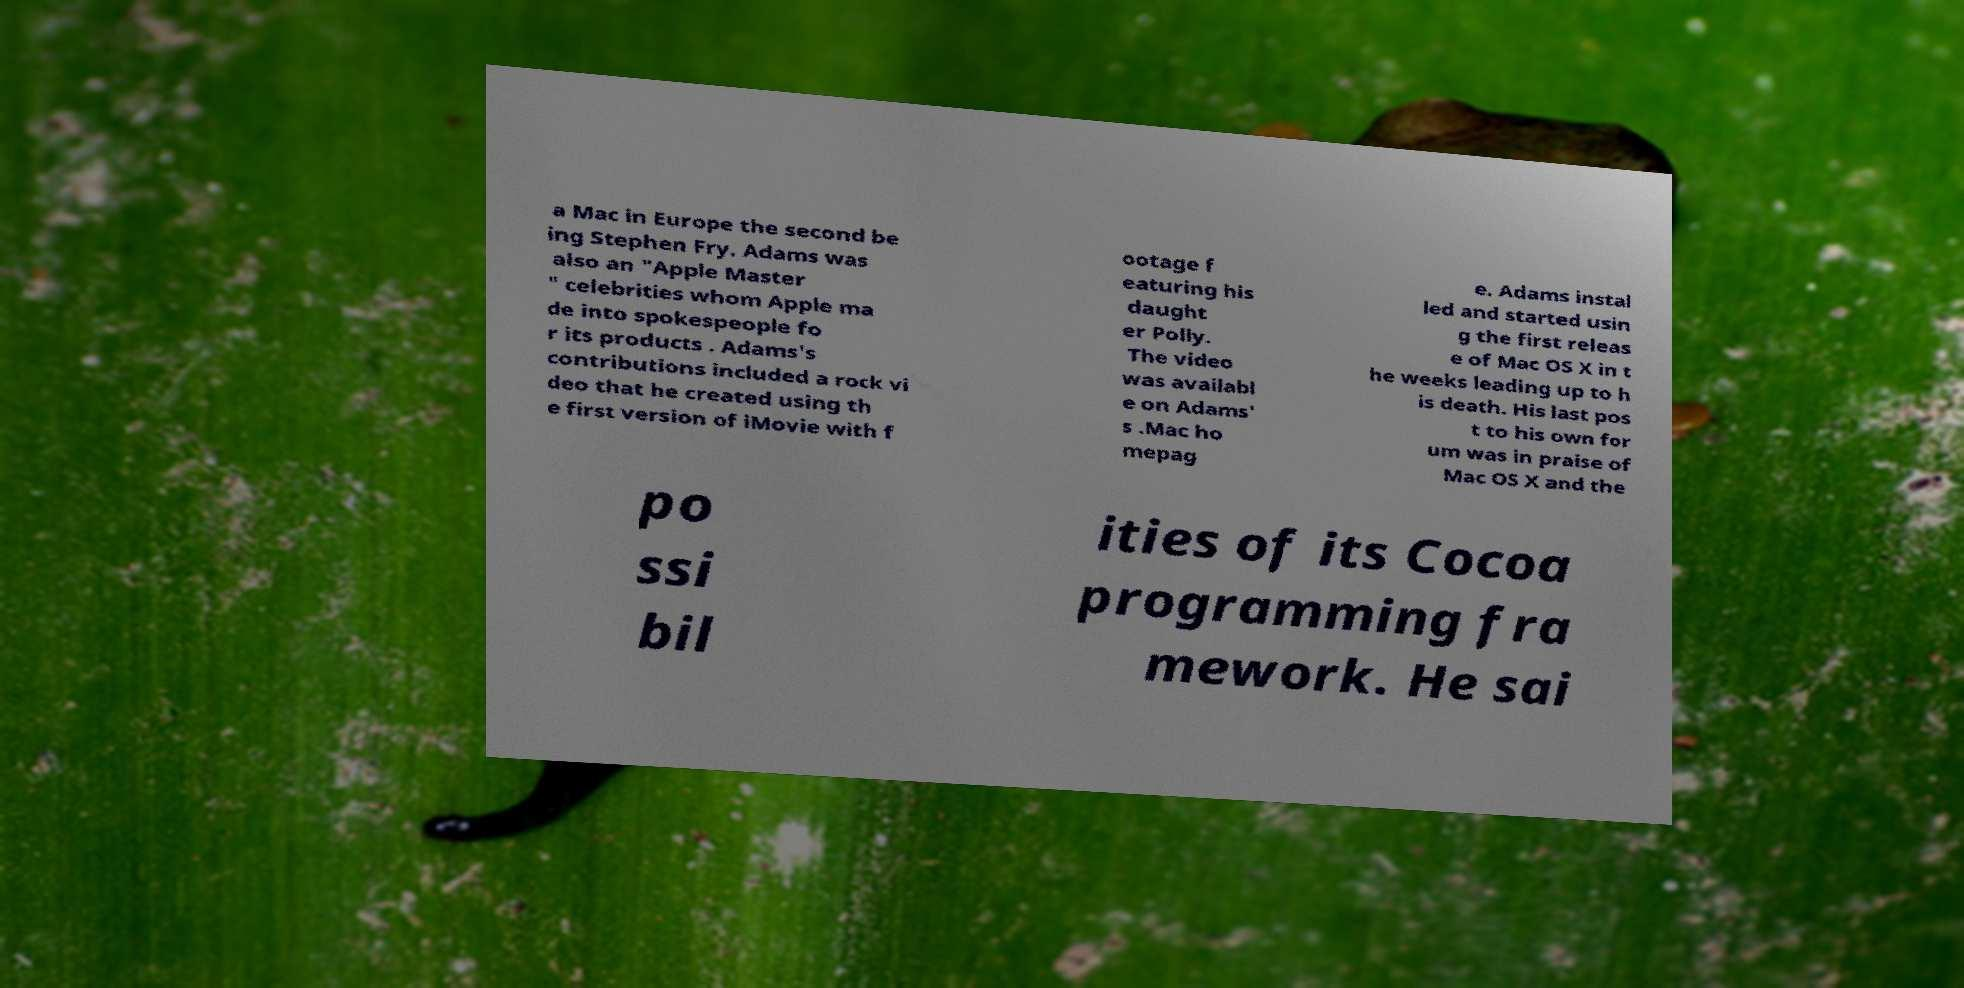Could you assist in decoding the text presented in this image and type it out clearly? a Mac in Europe the second be ing Stephen Fry. Adams was also an "Apple Master " celebrities whom Apple ma de into spokespeople fo r its products . Adams's contributions included a rock vi deo that he created using th e first version of iMovie with f ootage f eaturing his daught er Polly. The video was availabl e on Adams' s .Mac ho mepag e. Adams instal led and started usin g the first releas e of Mac OS X in t he weeks leading up to h is death. His last pos t to his own for um was in praise of Mac OS X and the po ssi bil ities of its Cocoa programming fra mework. He sai 